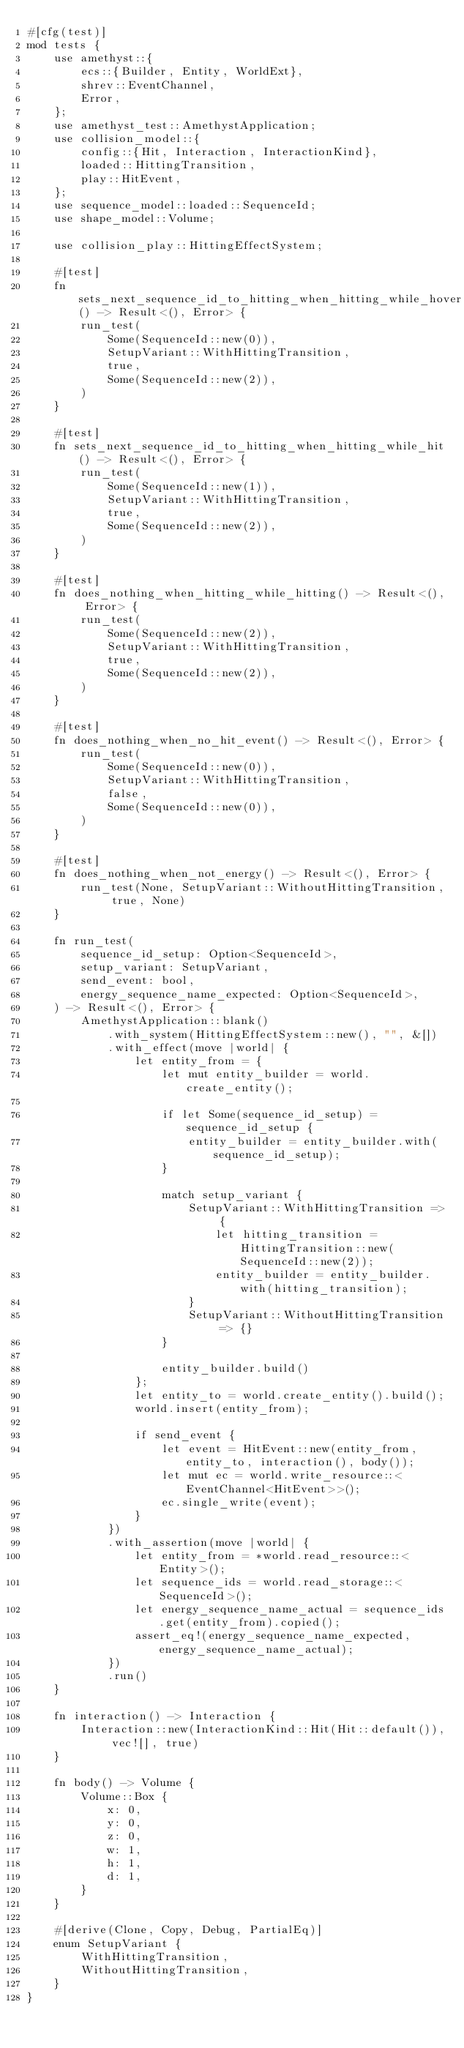<code> <loc_0><loc_0><loc_500><loc_500><_Rust_>#[cfg(test)]
mod tests {
    use amethyst::{
        ecs::{Builder, Entity, WorldExt},
        shrev::EventChannel,
        Error,
    };
    use amethyst_test::AmethystApplication;
    use collision_model::{
        config::{Hit, Interaction, InteractionKind},
        loaded::HittingTransition,
        play::HitEvent,
    };
    use sequence_model::loaded::SequenceId;
    use shape_model::Volume;

    use collision_play::HittingEffectSystem;

    #[test]
    fn sets_next_sequence_id_to_hitting_when_hitting_while_hover() -> Result<(), Error> {
        run_test(
            Some(SequenceId::new(0)),
            SetupVariant::WithHittingTransition,
            true,
            Some(SequenceId::new(2)),
        )
    }

    #[test]
    fn sets_next_sequence_id_to_hitting_when_hitting_while_hit() -> Result<(), Error> {
        run_test(
            Some(SequenceId::new(1)),
            SetupVariant::WithHittingTransition,
            true,
            Some(SequenceId::new(2)),
        )
    }

    #[test]
    fn does_nothing_when_hitting_while_hitting() -> Result<(), Error> {
        run_test(
            Some(SequenceId::new(2)),
            SetupVariant::WithHittingTransition,
            true,
            Some(SequenceId::new(2)),
        )
    }

    #[test]
    fn does_nothing_when_no_hit_event() -> Result<(), Error> {
        run_test(
            Some(SequenceId::new(0)),
            SetupVariant::WithHittingTransition,
            false,
            Some(SequenceId::new(0)),
        )
    }

    #[test]
    fn does_nothing_when_not_energy() -> Result<(), Error> {
        run_test(None, SetupVariant::WithoutHittingTransition, true, None)
    }

    fn run_test(
        sequence_id_setup: Option<SequenceId>,
        setup_variant: SetupVariant,
        send_event: bool,
        energy_sequence_name_expected: Option<SequenceId>,
    ) -> Result<(), Error> {
        AmethystApplication::blank()
            .with_system(HittingEffectSystem::new(), "", &[])
            .with_effect(move |world| {
                let entity_from = {
                    let mut entity_builder = world.create_entity();

                    if let Some(sequence_id_setup) = sequence_id_setup {
                        entity_builder = entity_builder.with(sequence_id_setup);
                    }

                    match setup_variant {
                        SetupVariant::WithHittingTransition => {
                            let hitting_transition = HittingTransition::new(SequenceId::new(2));
                            entity_builder = entity_builder.with(hitting_transition);
                        }
                        SetupVariant::WithoutHittingTransition => {}
                    }

                    entity_builder.build()
                };
                let entity_to = world.create_entity().build();
                world.insert(entity_from);

                if send_event {
                    let event = HitEvent::new(entity_from, entity_to, interaction(), body());
                    let mut ec = world.write_resource::<EventChannel<HitEvent>>();
                    ec.single_write(event);
                }
            })
            .with_assertion(move |world| {
                let entity_from = *world.read_resource::<Entity>();
                let sequence_ids = world.read_storage::<SequenceId>();
                let energy_sequence_name_actual = sequence_ids.get(entity_from).copied();
                assert_eq!(energy_sequence_name_expected, energy_sequence_name_actual);
            })
            .run()
    }

    fn interaction() -> Interaction {
        Interaction::new(InteractionKind::Hit(Hit::default()), vec![], true)
    }

    fn body() -> Volume {
        Volume::Box {
            x: 0,
            y: 0,
            z: 0,
            w: 1,
            h: 1,
            d: 1,
        }
    }

    #[derive(Clone, Copy, Debug, PartialEq)]
    enum SetupVariant {
        WithHittingTransition,
        WithoutHittingTransition,
    }
}
</code> 